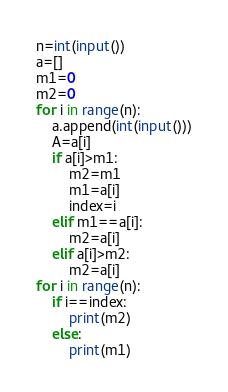Convert code to text. <code><loc_0><loc_0><loc_500><loc_500><_Python_>n=int(input())
a=[]
m1=0
m2=0
for i in range(n):
    a.append(int(input()))
    A=a[i]
    if a[i]>m1:
        m2=m1
        m1=a[i]
        index=i
    elif m1==a[i]:
        m2=a[i]
    elif a[i]>m2:
        m2=a[i]
for i in range(n):
    if i==index:
        print(m2)
    else:
        print(m1)</code> 